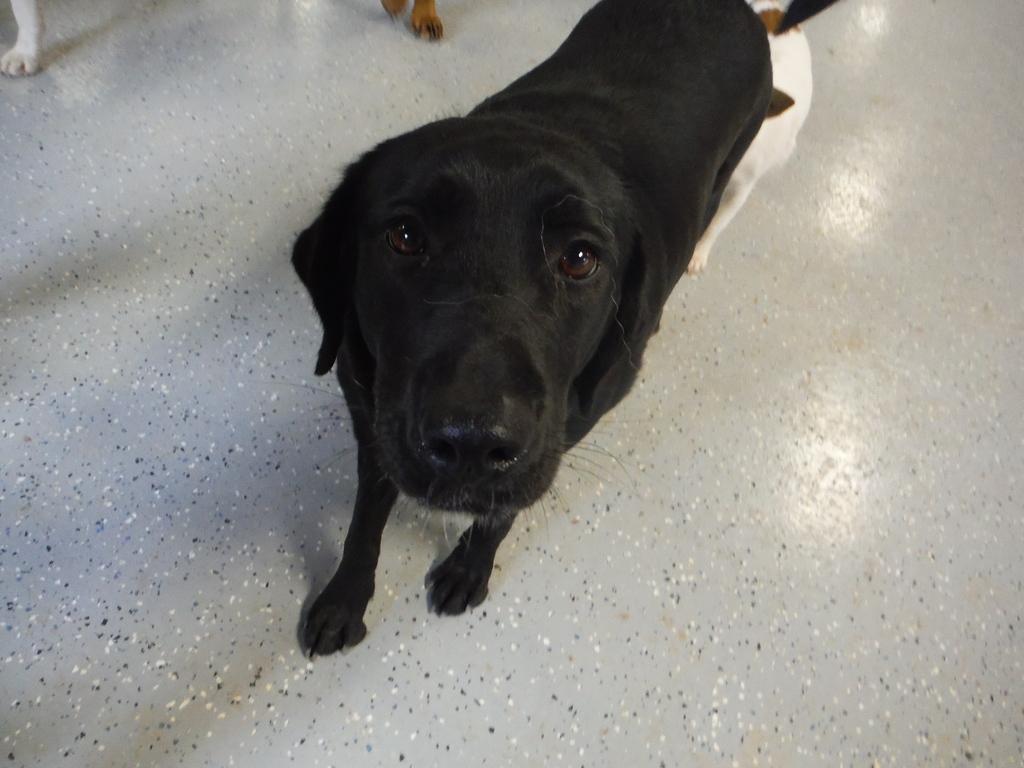Describe this image in one or two sentences. In this image I can see few dogs are standing on the floor. I can see the colour of these dogs are black, white and brown. 